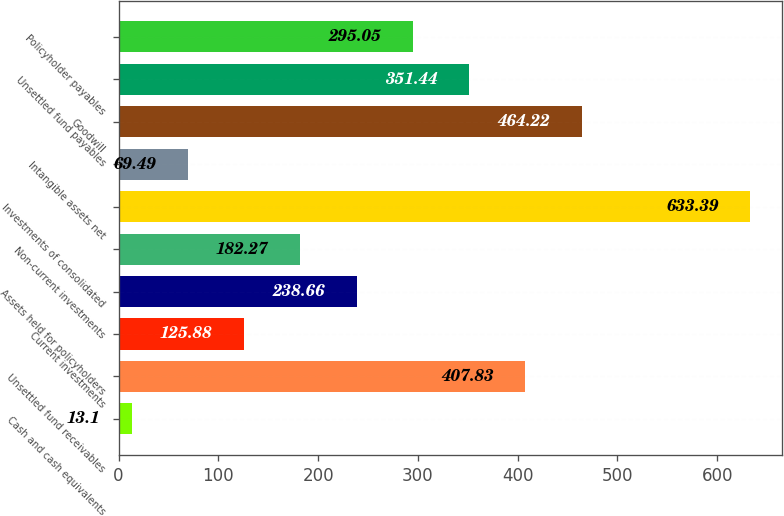Convert chart. <chart><loc_0><loc_0><loc_500><loc_500><bar_chart><fcel>Cash and cash equivalents<fcel>Unsettled fund receivables<fcel>Current investments<fcel>Assets held for policyholders<fcel>Non-current investments<fcel>Investments of consolidated<fcel>Intangible assets net<fcel>Goodwill<fcel>Unsettled fund payables<fcel>Policyholder payables<nl><fcel>13.1<fcel>407.83<fcel>125.88<fcel>238.66<fcel>182.27<fcel>633.39<fcel>69.49<fcel>464.22<fcel>351.44<fcel>295.05<nl></chart> 